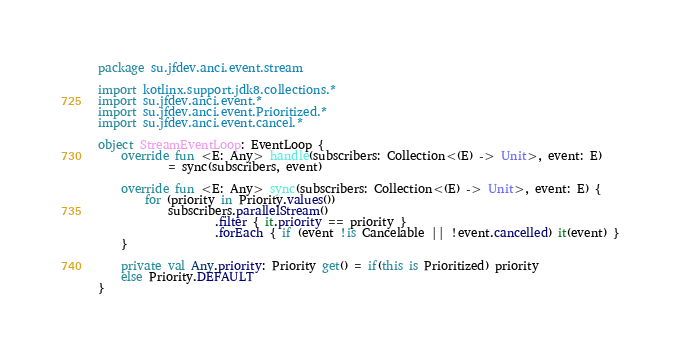Convert code to text. <code><loc_0><loc_0><loc_500><loc_500><_Kotlin_>package su.jfdev.anci.event.stream

import kotlinx.support.jdk8.collections.*
import su.jfdev.anci.event.*
import su.jfdev.anci.event.Prioritized.*
import su.jfdev.anci.event.cancel.*

object StreamEventLoop: EventLoop {
    override fun <E: Any> handle(subscribers: Collection<(E) -> Unit>, event: E)
            = sync(subscribers, event)

    override fun <E: Any> sync(subscribers: Collection<(E) -> Unit>, event: E) {
        for (priority in Priority.values())
            subscribers.parallelStream()
                    .filter { it.priority == priority }
                    .forEach { if (event !is Cancelable || !event.cancelled) it(event) }
    }

    private val Any.priority: Priority get() = if(this is Prioritized) priority
    else Priority.DEFAULT
}</code> 